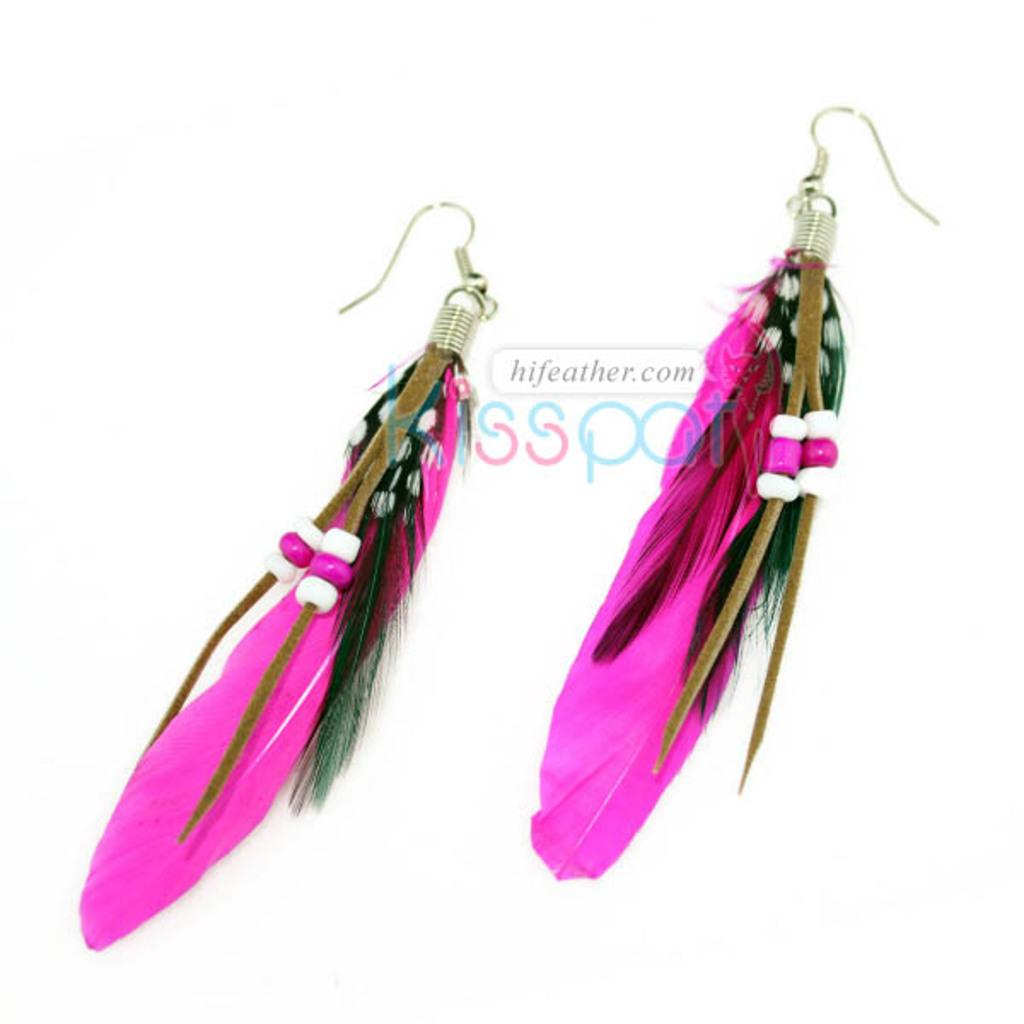What type of accessory is featured in the picture? There are earrings in the picture. What color and material are the feathers on the earrings? The earrings have pink-colored feathers. Where are the earrings placed in the picture? The earrings are placed over a surface or area. What type of powder is being used by the horses in the picture? There are no horses or powder present in the picture; it features earrings with pink-colored feathers. 